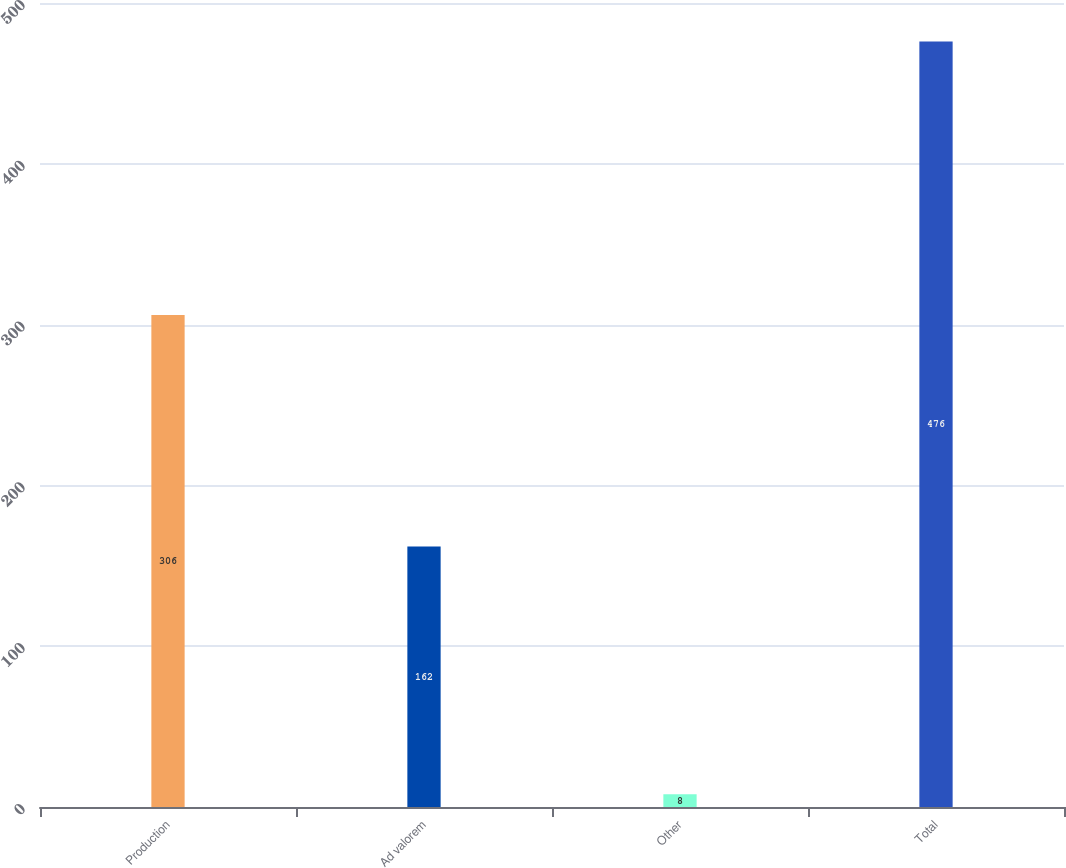Convert chart to OTSL. <chart><loc_0><loc_0><loc_500><loc_500><bar_chart><fcel>Production<fcel>Ad valorem<fcel>Other<fcel>Total<nl><fcel>306<fcel>162<fcel>8<fcel>476<nl></chart> 